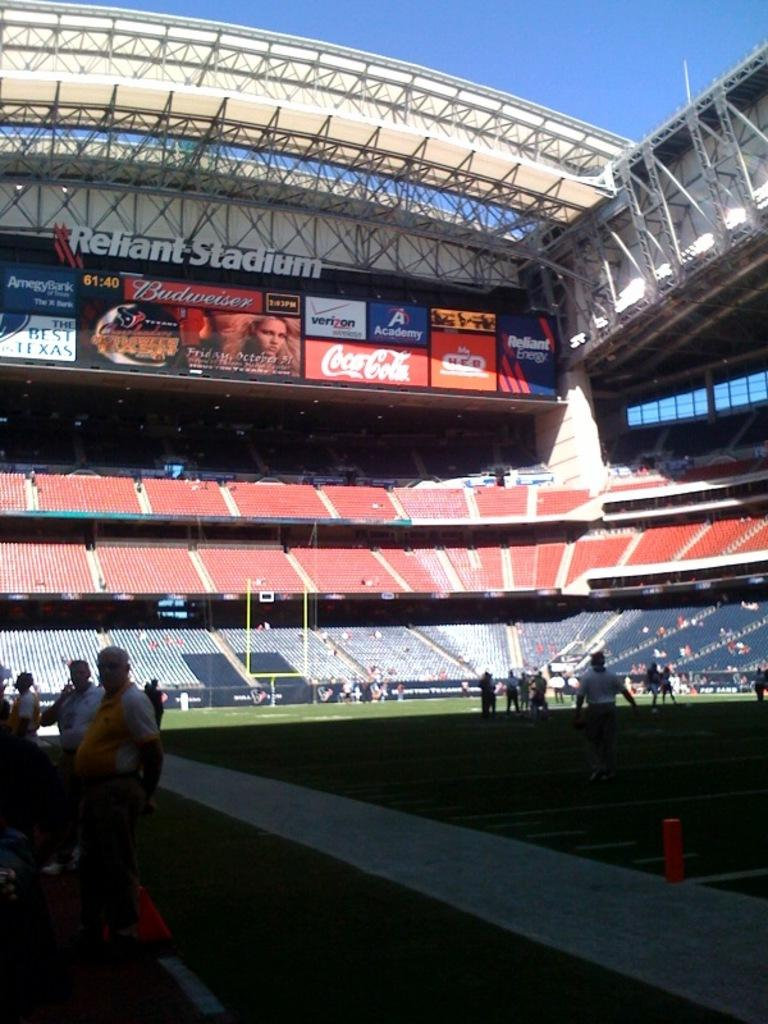<image>
Create a compact narrative representing the image presented. Reliant stadium with many billboards on it above the seats 